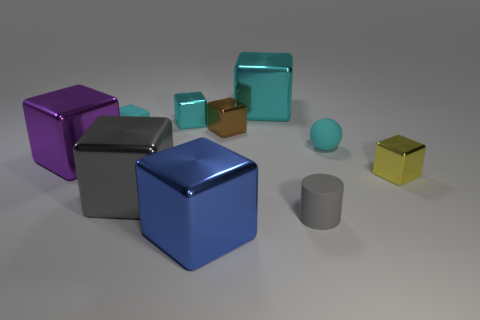There is a cyan rubber cube; what number of gray things are to the left of it? While observing the given image, there are no gray objects located to the left side of the cyan rubber cube. 